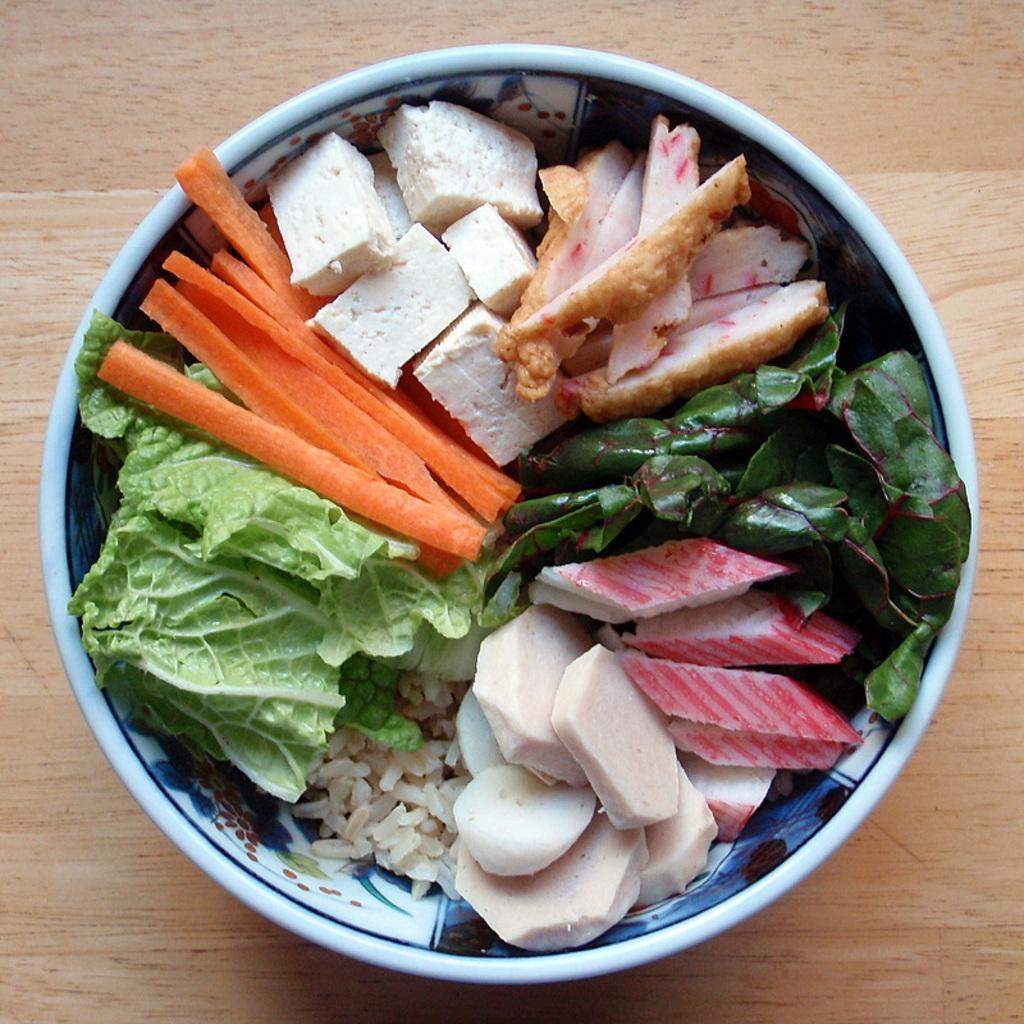Could you give a brief overview of what you see in this image? In this image we can see vegetables in bowl placed on the table. 